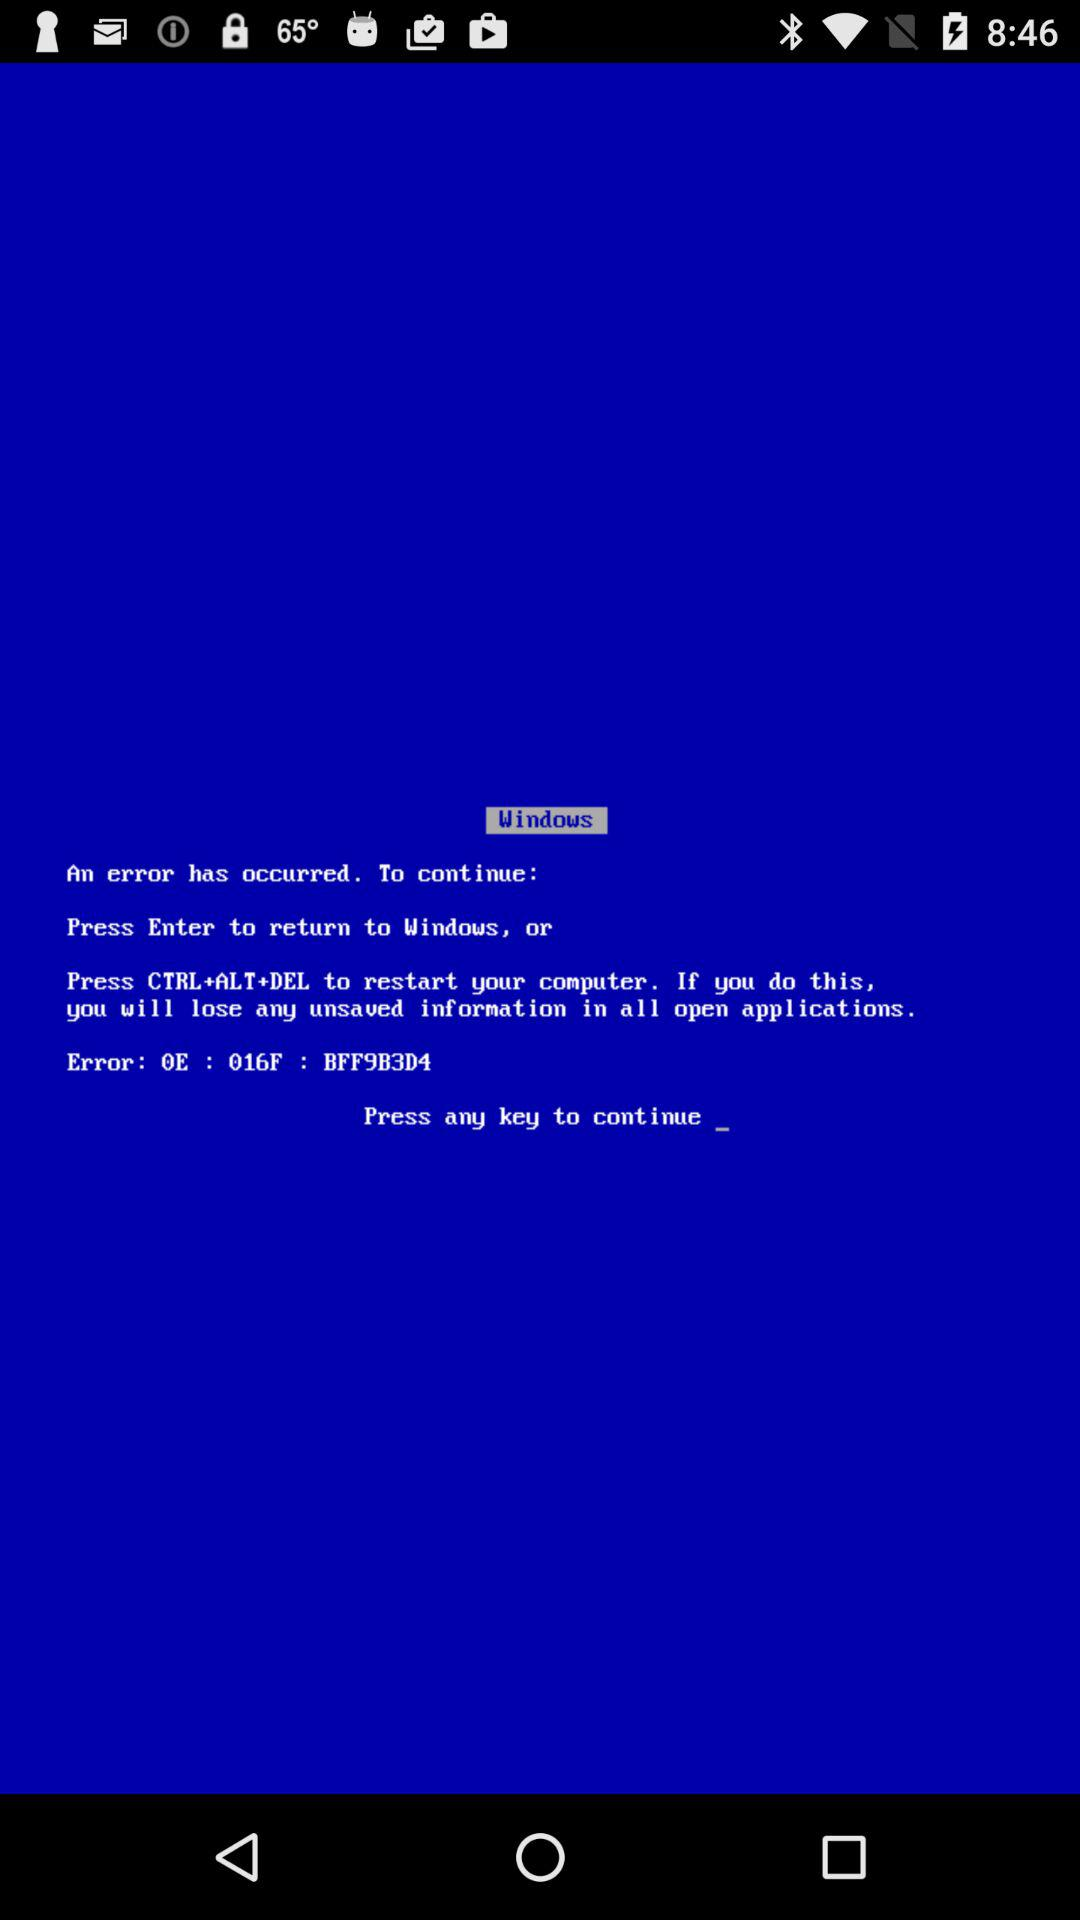What is the user's name?
When the provided information is insufficient, respond with <no answer>. <no answer> 